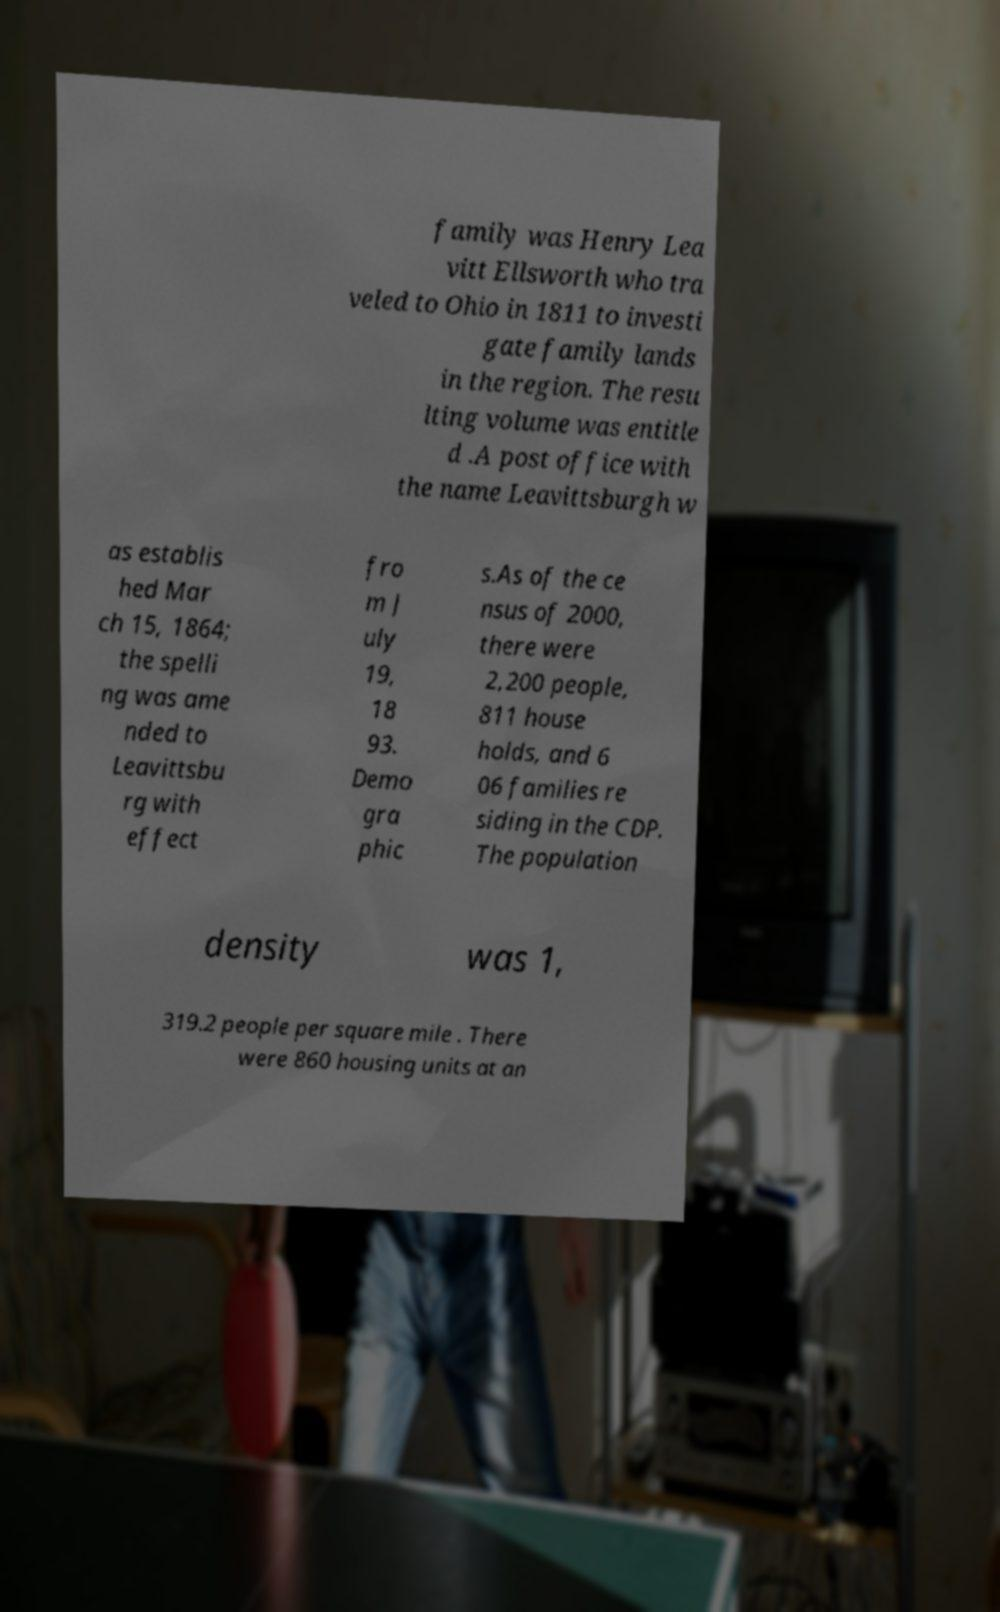What messages or text are displayed in this image? I need them in a readable, typed format. family was Henry Lea vitt Ellsworth who tra veled to Ohio in 1811 to investi gate family lands in the region. The resu lting volume was entitle d .A post office with the name Leavittsburgh w as establis hed Mar ch 15, 1864; the spelli ng was ame nded to Leavittsbu rg with effect fro m J uly 19, 18 93. Demo gra phic s.As of the ce nsus of 2000, there were 2,200 people, 811 house holds, and 6 06 families re siding in the CDP. The population density was 1, 319.2 people per square mile . There were 860 housing units at an 